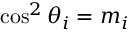<formula> <loc_0><loc_0><loc_500><loc_500>\cos ^ { 2 } \theta _ { i } = m _ { i }</formula> 